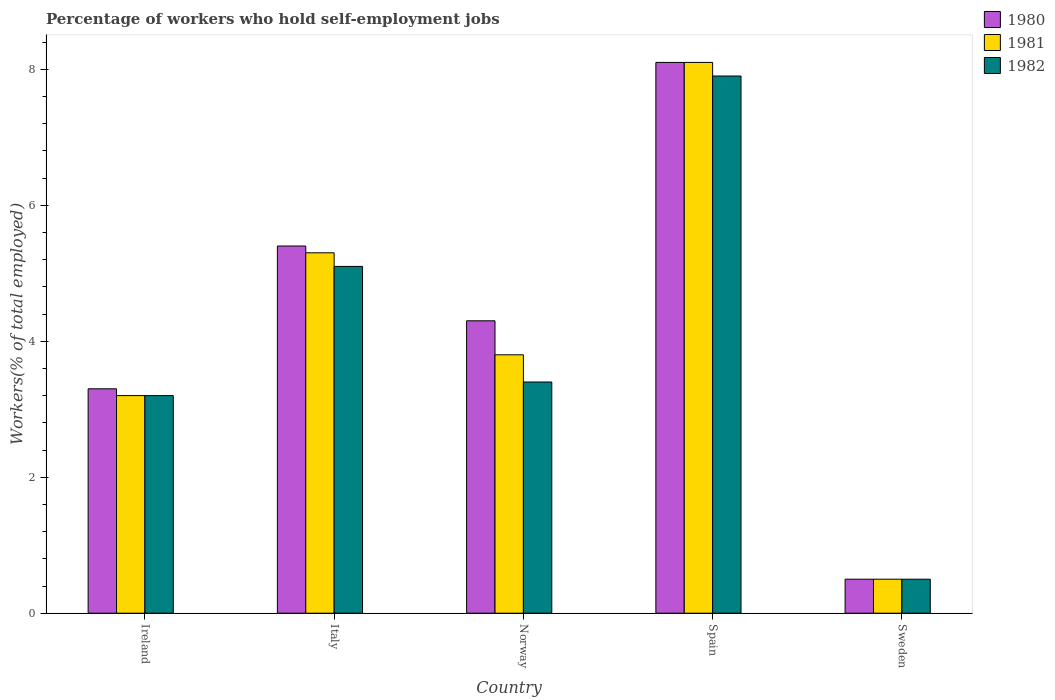Are the number of bars per tick equal to the number of legend labels?
Give a very brief answer. Yes. Are the number of bars on each tick of the X-axis equal?
Offer a terse response. Yes. How many bars are there on the 4th tick from the right?
Ensure brevity in your answer.  3. What is the label of the 3rd group of bars from the left?
Provide a short and direct response. Norway. In how many cases, is the number of bars for a given country not equal to the number of legend labels?
Provide a short and direct response. 0. What is the percentage of self-employed workers in 1980 in Norway?
Ensure brevity in your answer.  4.3. Across all countries, what is the maximum percentage of self-employed workers in 1980?
Keep it short and to the point. 8.1. Across all countries, what is the minimum percentage of self-employed workers in 1982?
Provide a succinct answer. 0.5. In which country was the percentage of self-employed workers in 1981 maximum?
Make the answer very short. Spain. In which country was the percentage of self-employed workers in 1980 minimum?
Keep it short and to the point. Sweden. What is the total percentage of self-employed workers in 1980 in the graph?
Provide a succinct answer. 21.6. What is the difference between the percentage of self-employed workers in 1980 in Ireland and that in Norway?
Your answer should be very brief. -1. What is the difference between the percentage of self-employed workers in 1981 in Italy and the percentage of self-employed workers in 1982 in Spain?
Provide a succinct answer. -2.6. What is the average percentage of self-employed workers in 1981 per country?
Keep it short and to the point. 4.18. In how many countries, is the percentage of self-employed workers in 1981 greater than 7.6 %?
Offer a terse response. 1. What is the ratio of the percentage of self-employed workers in 1981 in Norway to that in Sweden?
Ensure brevity in your answer.  7.6. Is the percentage of self-employed workers in 1980 in Norway less than that in Spain?
Offer a very short reply. Yes. Is the difference between the percentage of self-employed workers in 1982 in Ireland and Italy greater than the difference between the percentage of self-employed workers in 1981 in Ireland and Italy?
Keep it short and to the point. Yes. What is the difference between the highest and the second highest percentage of self-employed workers in 1982?
Keep it short and to the point. -1.7. What is the difference between the highest and the lowest percentage of self-employed workers in 1981?
Provide a short and direct response. 7.6. In how many countries, is the percentage of self-employed workers in 1981 greater than the average percentage of self-employed workers in 1981 taken over all countries?
Ensure brevity in your answer.  2. What does the 2nd bar from the left in Ireland represents?
Your response must be concise. 1981. How many bars are there?
Provide a succinct answer. 15. Are the values on the major ticks of Y-axis written in scientific E-notation?
Offer a terse response. No. Does the graph contain any zero values?
Offer a very short reply. No. How many legend labels are there?
Keep it short and to the point. 3. How are the legend labels stacked?
Keep it short and to the point. Vertical. What is the title of the graph?
Provide a short and direct response. Percentage of workers who hold self-employment jobs. Does "1986" appear as one of the legend labels in the graph?
Give a very brief answer. No. What is the label or title of the Y-axis?
Ensure brevity in your answer.  Workers(% of total employed). What is the Workers(% of total employed) of 1980 in Ireland?
Your answer should be very brief. 3.3. What is the Workers(% of total employed) in 1981 in Ireland?
Offer a terse response. 3.2. What is the Workers(% of total employed) of 1982 in Ireland?
Give a very brief answer. 3.2. What is the Workers(% of total employed) in 1980 in Italy?
Your response must be concise. 5.4. What is the Workers(% of total employed) of 1981 in Italy?
Your answer should be compact. 5.3. What is the Workers(% of total employed) in 1982 in Italy?
Your answer should be very brief. 5.1. What is the Workers(% of total employed) of 1980 in Norway?
Keep it short and to the point. 4.3. What is the Workers(% of total employed) of 1981 in Norway?
Your answer should be very brief. 3.8. What is the Workers(% of total employed) of 1982 in Norway?
Your response must be concise. 3.4. What is the Workers(% of total employed) in 1980 in Spain?
Ensure brevity in your answer.  8.1. What is the Workers(% of total employed) in 1981 in Spain?
Keep it short and to the point. 8.1. What is the Workers(% of total employed) in 1982 in Spain?
Keep it short and to the point. 7.9. What is the Workers(% of total employed) of 1981 in Sweden?
Your answer should be compact. 0.5. What is the Workers(% of total employed) of 1982 in Sweden?
Offer a terse response. 0.5. Across all countries, what is the maximum Workers(% of total employed) of 1980?
Offer a very short reply. 8.1. Across all countries, what is the maximum Workers(% of total employed) of 1981?
Your answer should be very brief. 8.1. Across all countries, what is the maximum Workers(% of total employed) in 1982?
Give a very brief answer. 7.9. Across all countries, what is the minimum Workers(% of total employed) in 1980?
Provide a short and direct response. 0.5. Across all countries, what is the minimum Workers(% of total employed) in 1981?
Your answer should be very brief. 0.5. Across all countries, what is the minimum Workers(% of total employed) of 1982?
Your response must be concise. 0.5. What is the total Workers(% of total employed) in 1980 in the graph?
Offer a terse response. 21.6. What is the total Workers(% of total employed) in 1981 in the graph?
Give a very brief answer. 20.9. What is the total Workers(% of total employed) of 1982 in the graph?
Your answer should be very brief. 20.1. What is the difference between the Workers(% of total employed) of 1981 in Ireland and that in Sweden?
Your response must be concise. 2.7. What is the difference between the Workers(% of total employed) of 1981 in Italy and that in Norway?
Offer a terse response. 1.5. What is the difference between the Workers(% of total employed) of 1982 in Italy and that in Norway?
Make the answer very short. 1.7. What is the difference between the Workers(% of total employed) in 1980 in Italy and that in Sweden?
Provide a succinct answer. 4.9. What is the difference between the Workers(% of total employed) of 1982 in Italy and that in Sweden?
Offer a terse response. 4.6. What is the difference between the Workers(% of total employed) in 1980 in Norway and that in Sweden?
Ensure brevity in your answer.  3.8. What is the difference between the Workers(% of total employed) of 1981 in Norway and that in Sweden?
Keep it short and to the point. 3.3. What is the difference between the Workers(% of total employed) in 1982 in Norway and that in Sweden?
Your answer should be compact. 2.9. What is the difference between the Workers(% of total employed) in 1980 in Ireland and the Workers(% of total employed) in 1981 in Italy?
Keep it short and to the point. -2. What is the difference between the Workers(% of total employed) of 1981 in Ireland and the Workers(% of total employed) of 1982 in Italy?
Offer a very short reply. -1.9. What is the difference between the Workers(% of total employed) in 1980 in Ireland and the Workers(% of total employed) in 1981 in Norway?
Make the answer very short. -0.5. What is the difference between the Workers(% of total employed) of 1980 in Ireland and the Workers(% of total employed) of 1982 in Sweden?
Provide a short and direct response. 2.8. What is the difference between the Workers(% of total employed) of 1980 in Italy and the Workers(% of total employed) of 1982 in Norway?
Make the answer very short. 2. What is the difference between the Workers(% of total employed) in 1981 in Italy and the Workers(% of total employed) in 1982 in Norway?
Your answer should be compact. 1.9. What is the difference between the Workers(% of total employed) in 1981 in Italy and the Workers(% of total employed) in 1982 in Spain?
Provide a short and direct response. -2.6. What is the difference between the Workers(% of total employed) in 1980 in Italy and the Workers(% of total employed) in 1982 in Sweden?
Your response must be concise. 4.9. What is the difference between the Workers(% of total employed) in 1981 in Italy and the Workers(% of total employed) in 1982 in Sweden?
Your answer should be very brief. 4.8. What is the difference between the Workers(% of total employed) in 1980 in Norway and the Workers(% of total employed) in 1981 in Spain?
Give a very brief answer. -3.8. What is the difference between the Workers(% of total employed) in 1980 in Norway and the Workers(% of total employed) in 1982 in Spain?
Ensure brevity in your answer.  -3.6. What is the difference between the Workers(% of total employed) in 1981 in Norway and the Workers(% of total employed) in 1982 in Spain?
Offer a very short reply. -4.1. What is the difference between the Workers(% of total employed) of 1981 in Norway and the Workers(% of total employed) of 1982 in Sweden?
Your answer should be very brief. 3.3. What is the difference between the Workers(% of total employed) of 1980 in Spain and the Workers(% of total employed) of 1982 in Sweden?
Your answer should be compact. 7.6. What is the average Workers(% of total employed) in 1980 per country?
Provide a short and direct response. 4.32. What is the average Workers(% of total employed) in 1981 per country?
Ensure brevity in your answer.  4.18. What is the average Workers(% of total employed) in 1982 per country?
Your answer should be compact. 4.02. What is the difference between the Workers(% of total employed) in 1980 and Workers(% of total employed) in 1982 in Ireland?
Offer a very short reply. 0.1. What is the difference between the Workers(% of total employed) of 1981 and Workers(% of total employed) of 1982 in Ireland?
Provide a short and direct response. 0. What is the difference between the Workers(% of total employed) in 1980 and Workers(% of total employed) in 1981 in Norway?
Your response must be concise. 0.5. What is the difference between the Workers(% of total employed) of 1980 and Workers(% of total employed) of 1981 in Spain?
Provide a succinct answer. 0. What is the difference between the Workers(% of total employed) in 1980 and Workers(% of total employed) in 1981 in Sweden?
Your response must be concise. 0. What is the difference between the Workers(% of total employed) of 1980 and Workers(% of total employed) of 1982 in Sweden?
Offer a very short reply. 0. What is the difference between the Workers(% of total employed) of 1981 and Workers(% of total employed) of 1982 in Sweden?
Keep it short and to the point. 0. What is the ratio of the Workers(% of total employed) of 1980 in Ireland to that in Italy?
Offer a very short reply. 0.61. What is the ratio of the Workers(% of total employed) in 1981 in Ireland to that in Italy?
Your response must be concise. 0.6. What is the ratio of the Workers(% of total employed) of 1982 in Ireland to that in Italy?
Keep it short and to the point. 0.63. What is the ratio of the Workers(% of total employed) in 1980 in Ireland to that in Norway?
Give a very brief answer. 0.77. What is the ratio of the Workers(% of total employed) in 1981 in Ireland to that in Norway?
Make the answer very short. 0.84. What is the ratio of the Workers(% of total employed) in 1980 in Ireland to that in Spain?
Provide a succinct answer. 0.41. What is the ratio of the Workers(% of total employed) in 1981 in Ireland to that in Spain?
Offer a very short reply. 0.4. What is the ratio of the Workers(% of total employed) of 1982 in Ireland to that in Spain?
Your response must be concise. 0.41. What is the ratio of the Workers(% of total employed) in 1980 in Ireland to that in Sweden?
Your answer should be very brief. 6.6. What is the ratio of the Workers(% of total employed) in 1980 in Italy to that in Norway?
Provide a short and direct response. 1.26. What is the ratio of the Workers(% of total employed) in 1981 in Italy to that in Norway?
Offer a very short reply. 1.39. What is the ratio of the Workers(% of total employed) in 1980 in Italy to that in Spain?
Offer a very short reply. 0.67. What is the ratio of the Workers(% of total employed) in 1981 in Italy to that in Spain?
Provide a short and direct response. 0.65. What is the ratio of the Workers(% of total employed) of 1982 in Italy to that in Spain?
Your answer should be very brief. 0.65. What is the ratio of the Workers(% of total employed) of 1982 in Italy to that in Sweden?
Provide a short and direct response. 10.2. What is the ratio of the Workers(% of total employed) in 1980 in Norway to that in Spain?
Give a very brief answer. 0.53. What is the ratio of the Workers(% of total employed) of 1981 in Norway to that in Spain?
Ensure brevity in your answer.  0.47. What is the ratio of the Workers(% of total employed) in 1982 in Norway to that in Spain?
Ensure brevity in your answer.  0.43. What is the ratio of the Workers(% of total employed) in 1980 in Norway to that in Sweden?
Give a very brief answer. 8.6. What is the ratio of the Workers(% of total employed) in 1981 in Norway to that in Sweden?
Your answer should be compact. 7.6. What is the ratio of the Workers(% of total employed) in 1980 in Spain to that in Sweden?
Your answer should be very brief. 16.2. What is the ratio of the Workers(% of total employed) of 1981 in Spain to that in Sweden?
Keep it short and to the point. 16.2. What is the difference between the highest and the second highest Workers(% of total employed) of 1981?
Offer a terse response. 2.8. What is the difference between the highest and the second highest Workers(% of total employed) in 1982?
Your answer should be compact. 2.8. What is the difference between the highest and the lowest Workers(% of total employed) of 1982?
Keep it short and to the point. 7.4. 